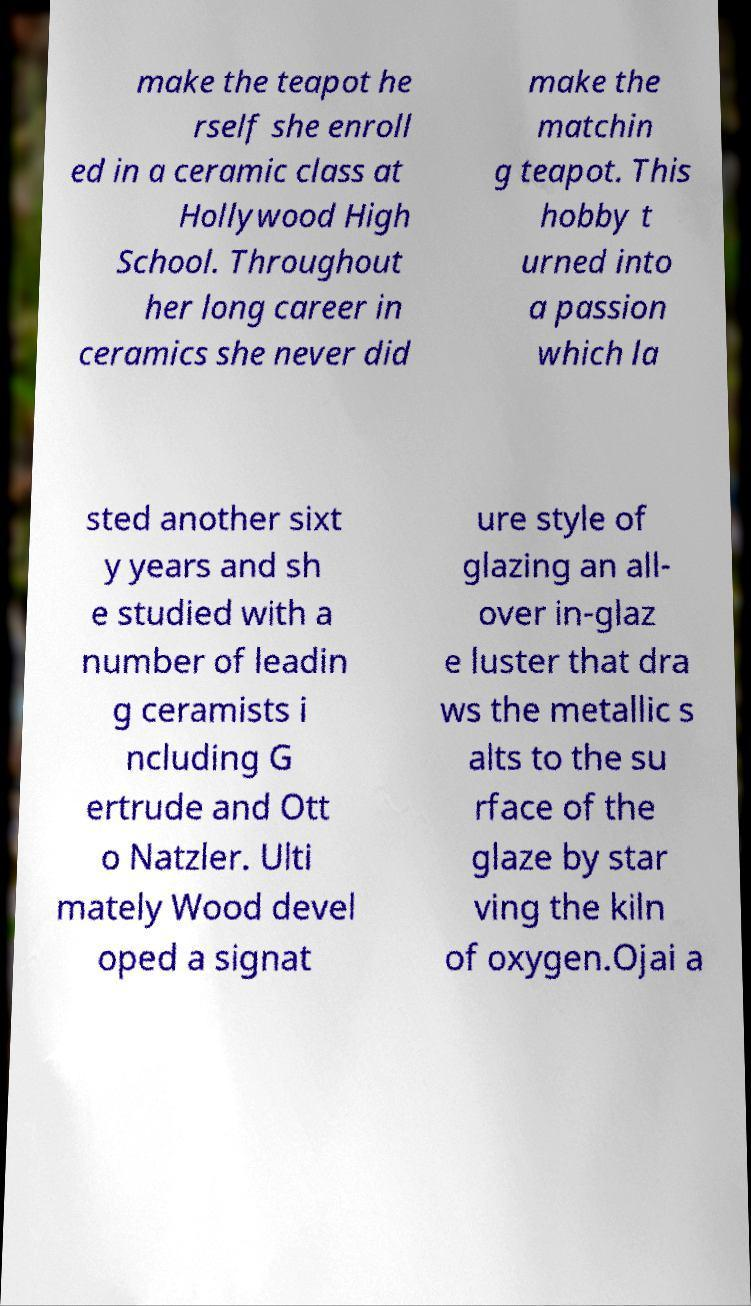There's text embedded in this image that I need extracted. Can you transcribe it verbatim? make the teapot he rself she enroll ed in a ceramic class at Hollywood High School. Throughout her long career in ceramics she never did make the matchin g teapot. This hobby t urned into a passion which la sted another sixt y years and sh e studied with a number of leadin g ceramists i ncluding G ertrude and Ott o Natzler. Ulti mately Wood devel oped a signat ure style of glazing an all- over in-glaz e luster that dra ws the metallic s alts to the su rface of the glaze by star ving the kiln of oxygen.Ojai a 